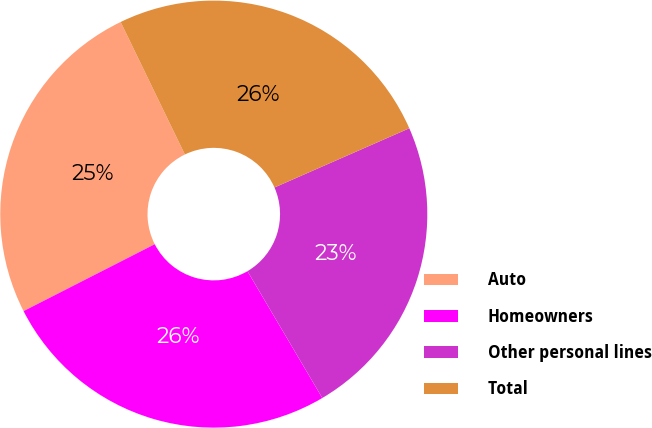Convert chart. <chart><loc_0><loc_0><loc_500><loc_500><pie_chart><fcel>Auto<fcel>Homeowners<fcel>Other personal lines<fcel>Total<nl><fcel>25.32%<fcel>25.98%<fcel>23.1%<fcel>25.6%<nl></chart> 